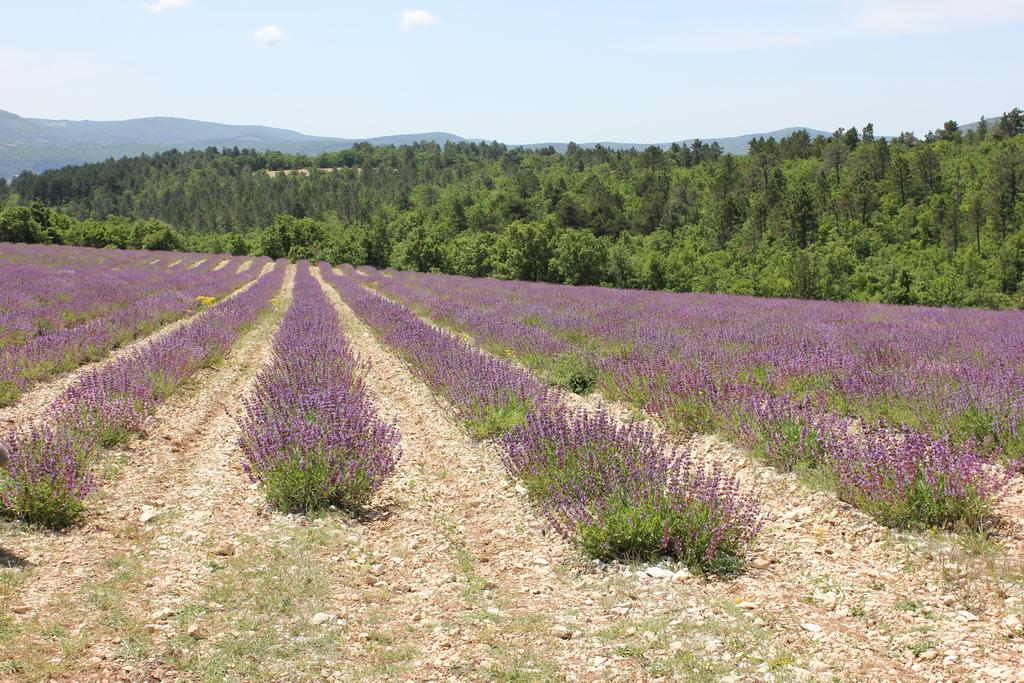What type of vegetation can be seen in the field? There are plants and grass in the field. What other objects can be found in the field? There are stones in the field. What else is visible in the image besides the field? There are trees, mountains, and clouds in the image. What type of produce is being sold on the street in the image? There is no street or produce present in the image. What type of wool is being used to make the clothing in the image? There is no clothing or wool present in the image. 